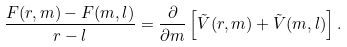Convert formula to latex. <formula><loc_0><loc_0><loc_500><loc_500>\frac { F ( r , m ) - F ( m , l ) } { r - l } = \frac { \partial } { \partial m } \left [ \tilde { V } ( r , m ) + \tilde { V } ( m , l ) \right ] .</formula> 